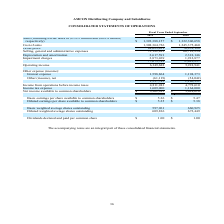From Amcon Distributing's financial document, What are the respective sales in the fiscal years ended September 2018 and 2019? The document shows two values: $1,322,306,658 and $1,392,388,157. From the document: "respectively) $ 1,392,388,157 $ 1,322,306,658 respectively) $ 1,392,388,157 $ 1,322,306,658..." Also, What are the respective cost of sales in the fiscal years ended September 2018 and 2019? The document shows two values: 1,245,375,460 and 1,308,364,726. From the document: "Cost of sales 1,308,364,726 1,245,375,460 Cost of sales 1,308,364,726 1,245,375,460..." Also, What are the respective gross profit in the fiscal years ended September 2018 and 2019? The document shows two values: 76,931,198 and 84,023,431. From the document: "Gross profit 84,023,431 76,931,198 Gross profit 84,023,431 76,931,198..." Also, can you calculate: What is the percentage change in the company's sales between the fiscal years ended September 2018 and 2019? To answer this question, I need to perform calculations using the financial data. The calculation is: (1,392,388,157 - 1,322,306,658)/1,322,306,658 , which equals 5.3 (percentage). This is based on the information: "respectively) $ 1,392,388,157 $ 1,322,306,658 respectively) $ 1,392,388,157 $ 1,322,306,658..." The key data points involved are: 1,322,306,658, 1,392,388,157. Also, can you calculate: What is the percentage change in the company's cost of sales between the fiscal years ended September 2018 and 2019? To answer this question, I need to perform calculations using the financial data. The calculation is: (1,308,364,726 - 1,245,375,460)/1,245,375,460 , which equals 5.06 (percentage). This is based on the information: "Cost of sales 1,308,364,726 1,245,375,460 Cost of sales 1,308,364,726 1,245,375,460..." The key data points involved are: 1,245,375,460, 1,308,364,726. Also, can you calculate: What is the percentage change in the company's gross profit between the fiscal years ended September 2018 and 2019? To answer this question, I need to perform calculations using the financial data. The calculation is: (84,023,431 - 76,931,198)/76,931,198 , which equals 9.22 (percentage). This is based on the information: "Gross profit 84,023,431 76,931,198 Gross profit 84,023,431 76,931,198..." The key data points involved are: 76,931,198, 84,023,431. 